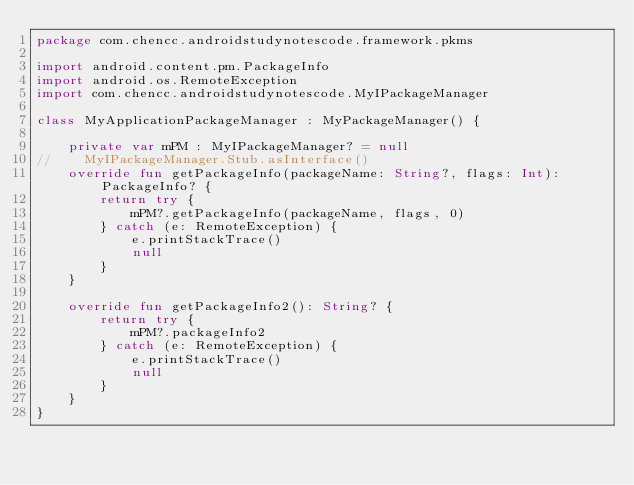<code> <loc_0><loc_0><loc_500><loc_500><_Kotlin_>package com.chencc.androidstudynotescode.framework.pkms

import android.content.pm.PackageInfo
import android.os.RemoteException
import com.chencc.androidstudynotescode.MyIPackageManager

class MyApplicationPackageManager : MyPackageManager() {

    private var mPM : MyIPackageManager? = null
//    MyIPackageManager.Stub.asInterface()
    override fun getPackageInfo(packageName: String?, flags: Int): PackageInfo? {
        return try {
            mPM?.getPackageInfo(packageName, flags, 0)
        } catch (e: RemoteException) {
            e.printStackTrace()
            null
        }
    }

    override fun getPackageInfo2(): String? {
        return try {
            mPM?.packageInfo2
        } catch (e: RemoteException) {
            e.printStackTrace()
            null
        }
    }
}</code> 